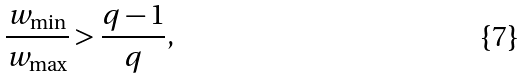Convert formula to latex. <formula><loc_0><loc_0><loc_500><loc_500>\frac { w _ { \min } } { w _ { \max } } > \frac { q - 1 } { q } ,</formula> 